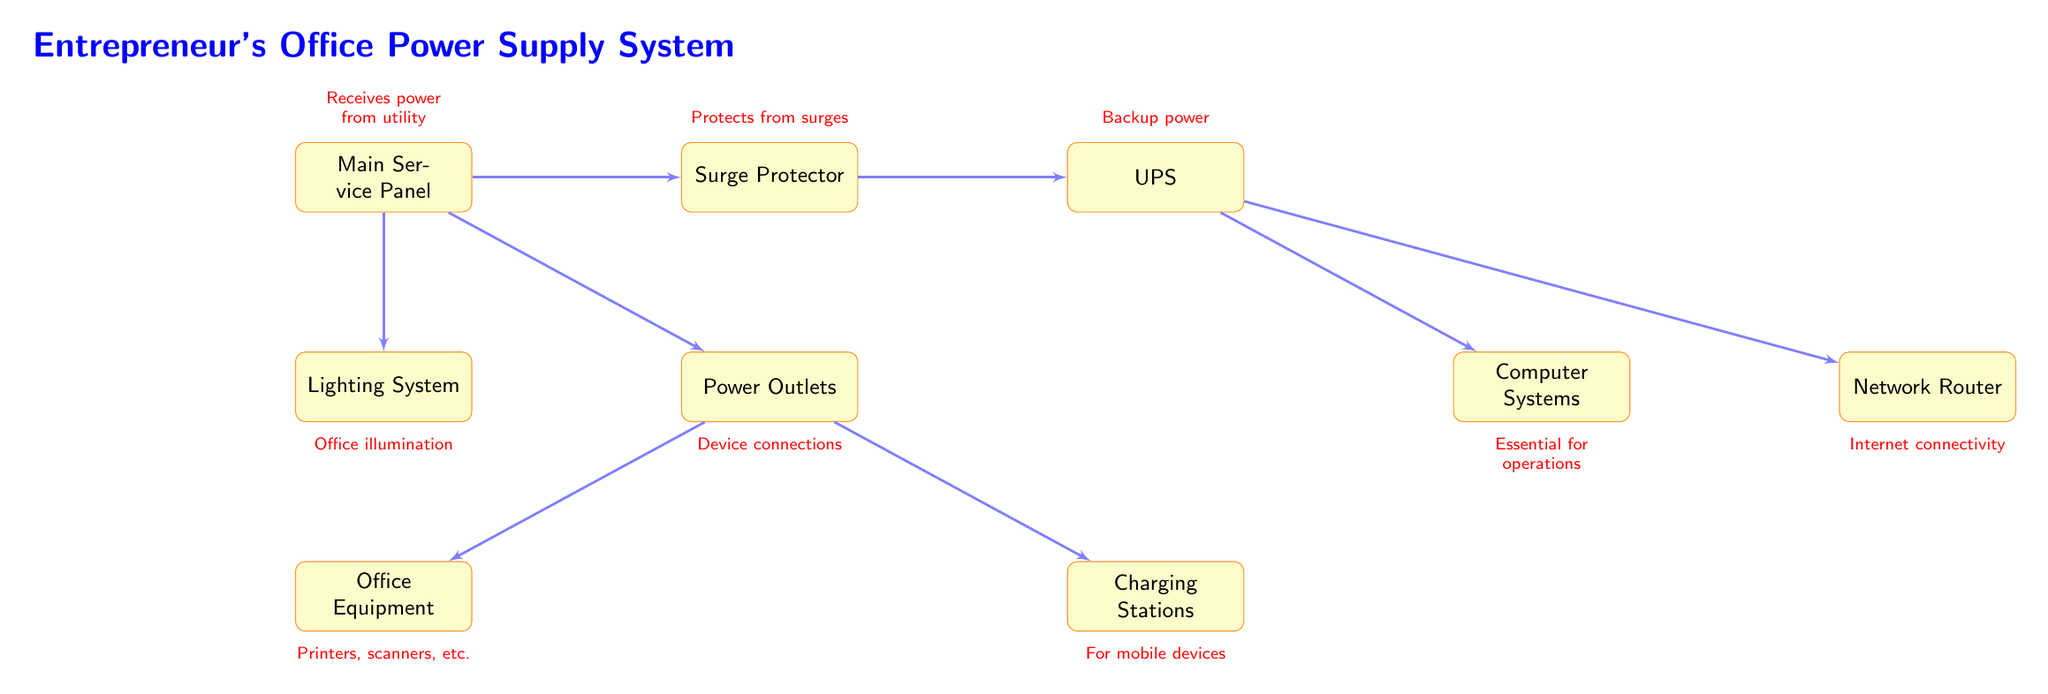What does the 'Main Service Panel' receive power from? The 'Main Service Panel' is connected to a utility source for power supply. This connection is marked in the diagram, indicating that it is the starting point of the power delivery system.
Answer: utility How many nodes are in the diagram? The diagram contains nine nodes, which include the 'Main Service Panel', 'Surge Protector', 'UPS', 'Lighting System', 'Power Outlets', 'Computer Systems', 'Network Router', 'Office Equipment', and 'Charging Stations'. Each of these is represented as a distinct box in the diagram.
Answer: nine What protects the office from surges? The 'Surge Protector' node is shown in the diagram, connected to the 'Main Service Panel' and is labeled to indicate its purpose of protecting the office from electrical surges, thus allowing for safe operation of the connected devices.
Answer: Surge Protector Which node provides backup power? The 'UPS' (Uninterruptible Power Supply) node is specifically labeled to indicate that it provides backup power, linking directly from the 'Surge Protector'. This suggests its role in maintaining power supply during outages.
Answer: UPS What are the essential systems powered by the UPS? The 'Computer Systems' and 'Network Router' are both connected to the 'UPS', indicating that these nodes are powered by the backup system, ensuring they remain operational in case of primary power failure.
Answer: Computer Systems, Network Router What is the function of the 'Lighting System'? The 'Lighting System' is connected directly to the 'Main Service Panel', and it is labeled to indicate its primary purpose which is office illumination, ensuring visibility and suitable working conditions.
Answer: Office illumination How many devices are connected to the 'Power Outlets'? Two devices are directly connected to the 'Power Outlets': 'Office Equipment' and 'Charging Stations'. Each of these nodes is clearly drawn with connections leading from the 'Power Outlets', representing device connectivity for power supply.
Answer: two Where does the power flow after the Surge Protector? After the 'Surge Protector', the power flows to the 'UPS', based on the directed arrow connecting these two nodes. This flow is crucial as it indicates where protection and backup preparation occur in the power supply system.
Answer: UPS What type of devices might be included in 'Office Equipment'? The label refers to general office devices such as printers and scanners. Given that 'Office Equipment' is positioned under 'Power Outlets', it suggests this is a broad category of devices needing power in an entrepreneurial setting.
Answer: Printers, scanners, etc 